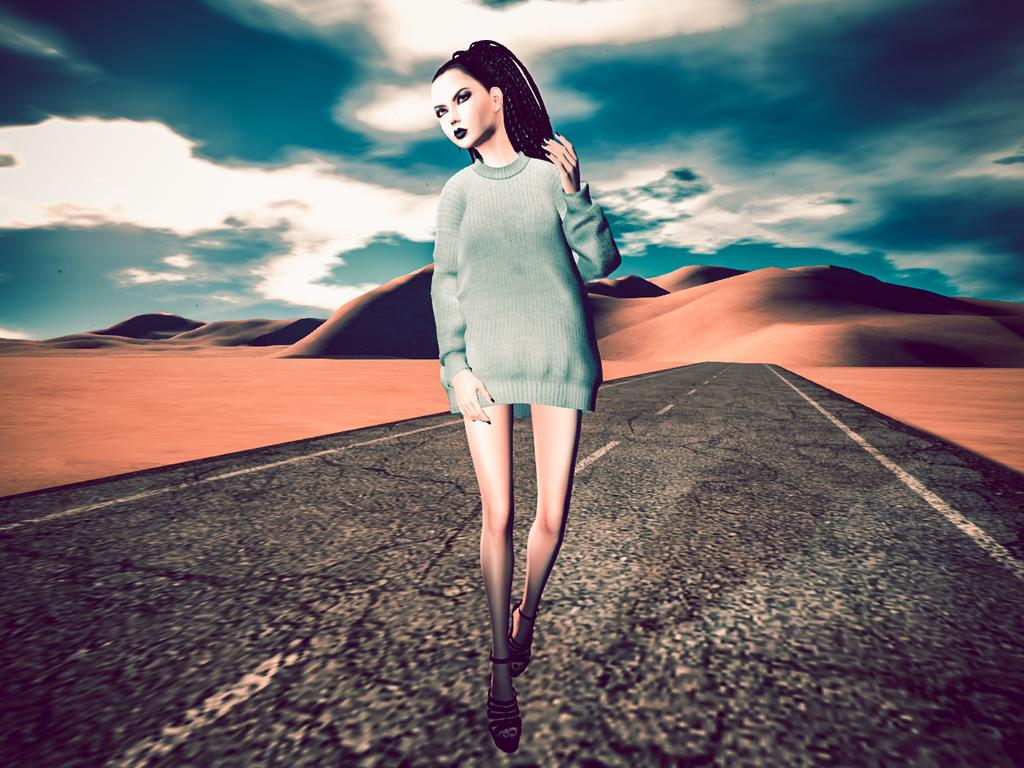What type of image is being described? The image is an edited picture. What is the main subject of the image? There is a person standing on the road in the center of the image. What can be seen in the background of the image? The sky, clouds, and hills are visible in the background of the image. What hobbies does the person in the image have? There is no information about the person's hobbies in the image. In which month was the image taken? There is no information about the month in which the image was taken. 